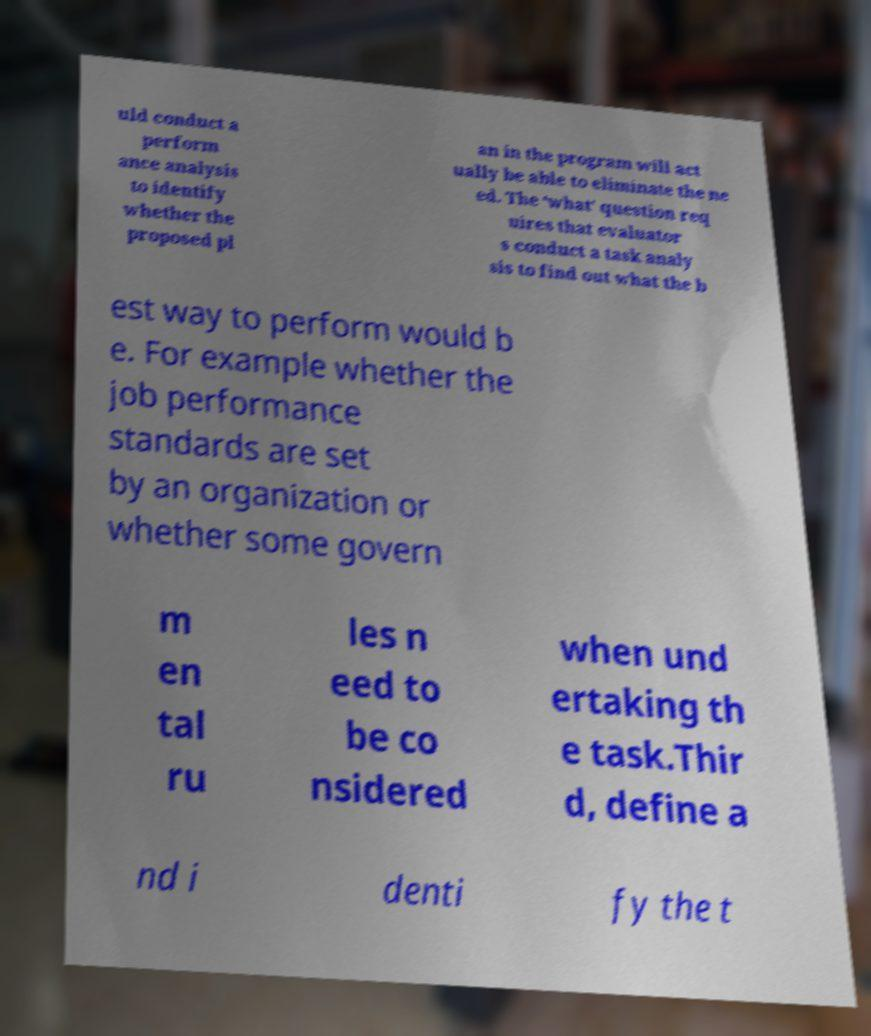Could you extract and type out the text from this image? uld conduct a perform ance analysis to identify whether the proposed pl an in the program will act ually be able to eliminate the ne ed. The ‘what’ question req uires that evaluator s conduct a task analy sis to find out what the b est way to perform would b e. For example whether the job performance standards are set by an organization or whether some govern m en tal ru les n eed to be co nsidered when und ertaking th e task.Thir d, define a nd i denti fy the t 